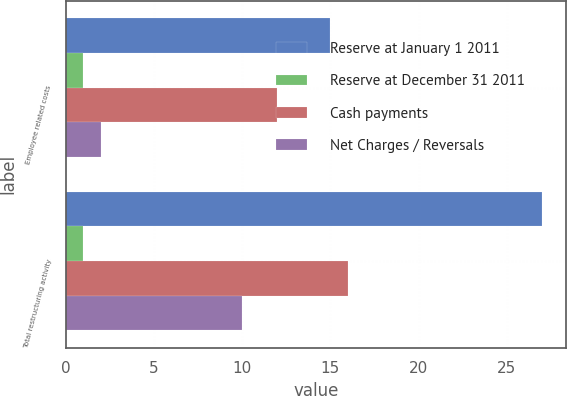Convert chart. <chart><loc_0><loc_0><loc_500><loc_500><stacked_bar_chart><ecel><fcel>Employee related costs<fcel>Total restructuring activity<nl><fcel>Reserve at January 1 2011<fcel>15<fcel>27<nl><fcel>Reserve at December 31 2011<fcel>1<fcel>1<nl><fcel>Cash payments<fcel>12<fcel>16<nl><fcel>Net Charges / Reversals<fcel>2<fcel>10<nl></chart> 